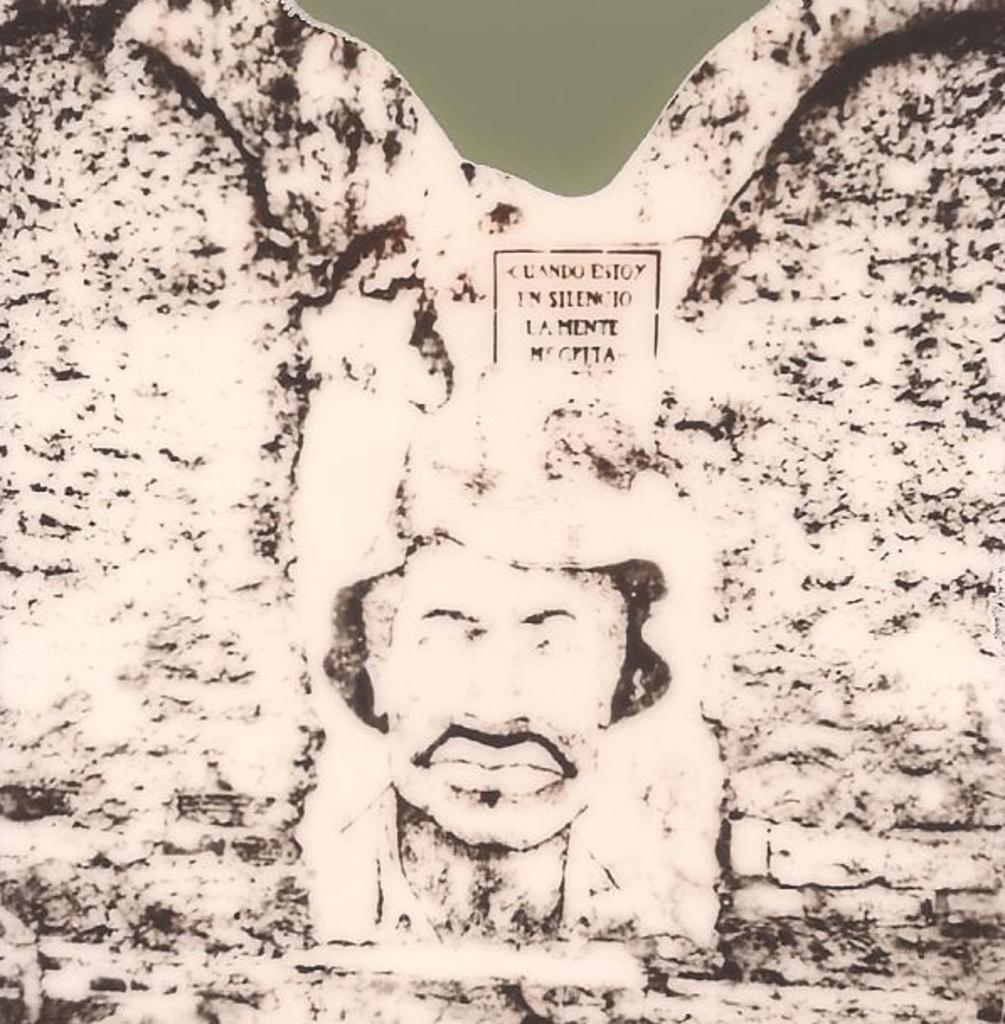What is the main feature of the image? There is a wall in the image. What is depicted on the wall? The face of a person is depicted on the wall. Are there any words or letters on the wall? Yes, there is text on the wall. What type of fruit is hanging from the wall in the image? There is no fruit hanging from the wall in the image. Can you tell me how many owls are depicted on the wall? There are no owls depicted on the wall; it features the face of a person and text. 